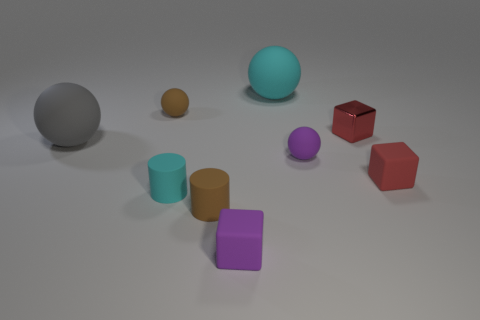There is a cyan object that is the same shape as the gray rubber object; what is its material?
Keep it short and to the point. Rubber. There is a brown rubber thing that is behind the red matte block; is its shape the same as the red shiny thing?
Your answer should be very brief. No. Is there anything else that is the same size as the gray thing?
Your answer should be compact. Yes. Is the number of tiny brown rubber balls that are right of the purple matte cube less than the number of tiny red shiny objects right of the red matte object?
Provide a short and direct response. No. How many other things are the same shape as the small red shiny thing?
Your answer should be compact. 2. What size is the purple thing that is on the left side of the cyan thing that is behind the cyan matte thing in front of the big cyan object?
Your answer should be very brief. Small. What number of red objects are either cylinders or small metallic blocks?
Provide a short and direct response. 1. There is a cyan object that is behind the big matte ball to the left of the cyan rubber cylinder; what is its shape?
Offer a terse response. Sphere. Do the red thing that is behind the big gray ball and the brown object that is behind the red rubber block have the same size?
Provide a short and direct response. Yes. Is there a small gray ball that has the same material as the cyan sphere?
Your answer should be very brief. No. 